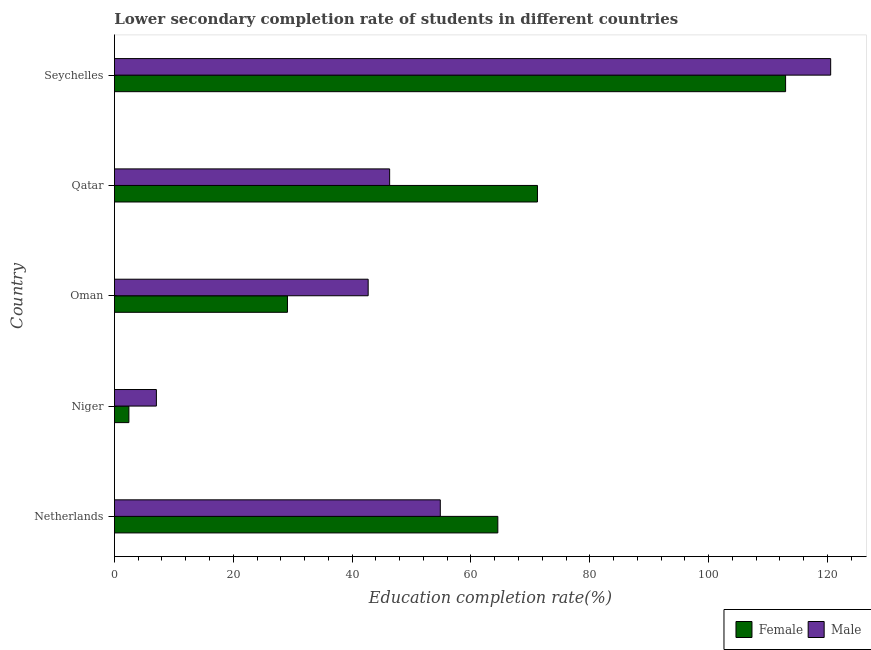How many different coloured bars are there?
Make the answer very short. 2. How many groups of bars are there?
Your response must be concise. 5. Are the number of bars per tick equal to the number of legend labels?
Give a very brief answer. Yes. How many bars are there on the 5th tick from the top?
Your answer should be compact. 2. What is the label of the 5th group of bars from the top?
Your answer should be very brief. Netherlands. What is the education completion rate of male students in Seychelles?
Provide a short and direct response. 120.54. Across all countries, what is the maximum education completion rate of female students?
Your response must be concise. 112.95. Across all countries, what is the minimum education completion rate of female students?
Give a very brief answer. 2.43. In which country was the education completion rate of female students maximum?
Offer a terse response. Seychelles. In which country was the education completion rate of male students minimum?
Offer a terse response. Niger. What is the total education completion rate of male students in the graph?
Give a very brief answer. 271.46. What is the difference between the education completion rate of female students in Netherlands and that in Seychelles?
Your answer should be very brief. -48.43. What is the difference between the education completion rate of male students in Niger and the education completion rate of female students in Qatar?
Give a very brief answer. -64.13. What is the average education completion rate of female students per country?
Provide a succinct answer. 56.05. What is the difference between the education completion rate of male students and education completion rate of female students in Netherlands?
Offer a terse response. -9.68. What is the ratio of the education completion rate of female students in Oman to that in Seychelles?
Keep it short and to the point. 0.26. Is the difference between the education completion rate of male students in Netherlands and Qatar greater than the difference between the education completion rate of female students in Netherlands and Qatar?
Your answer should be very brief. Yes. What is the difference between the highest and the second highest education completion rate of male students?
Offer a very short reply. 65.7. What is the difference between the highest and the lowest education completion rate of female students?
Offer a terse response. 110.52. Is the sum of the education completion rate of male students in Qatar and Seychelles greater than the maximum education completion rate of female students across all countries?
Provide a succinct answer. Yes. What does the 1st bar from the bottom in Netherlands represents?
Offer a terse response. Female. How many bars are there?
Give a very brief answer. 10. How many countries are there in the graph?
Provide a succinct answer. 5. Are the values on the major ticks of X-axis written in scientific E-notation?
Provide a short and direct response. No. Does the graph contain any zero values?
Your response must be concise. No. Does the graph contain grids?
Ensure brevity in your answer.  No. Where does the legend appear in the graph?
Offer a very short reply. Bottom right. How many legend labels are there?
Provide a succinct answer. 2. How are the legend labels stacked?
Give a very brief answer. Horizontal. What is the title of the graph?
Make the answer very short. Lower secondary completion rate of students in different countries. What is the label or title of the X-axis?
Provide a succinct answer. Education completion rate(%). What is the Education completion rate(%) in Female in Netherlands?
Offer a very short reply. 64.52. What is the Education completion rate(%) in Male in Netherlands?
Your response must be concise. 54.84. What is the Education completion rate(%) of Female in Niger?
Keep it short and to the point. 2.43. What is the Education completion rate(%) in Male in Niger?
Keep it short and to the point. 7.06. What is the Education completion rate(%) in Female in Oman?
Your response must be concise. 29.12. What is the Education completion rate(%) of Male in Oman?
Provide a short and direct response. 42.7. What is the Education completion rate(%) of Female in Qatar?
Provide a short and direct response. 71.19. What is the Education completion rate(%) in Male in Qatar?
Ensure brevity in your answer.  46.32. What is the Education completion rate(%) of Female in Seychelles?
Your answer should be compact. 112.95. What is the Education completion rate(%) of Male in Seychelles?
Your response must be concise. 120.54. Across all countries, what is the maximum Education completion rate(%) of Female?
Keep it short and to the point. 112.95. Across all countries, what is the maximum Education completion rate(%) of Male?
Provide a short and direct response. 120.54. Across all countries, what is the minimum Education completion rate(%) of Female?
Offer a very short reply. 2.43. Across all countries, what is the minimum Education completion rate(%) of Male?
Offer a terse response. 7.06. What is the total Education completion rate(%) of Female in the graph?
Your answer should be compact. 280.23. What is the total Education completion rate(%) of Male in the graph?
Give a very brief answer. 271.46. What is the difference between the Education completion rate(%) of Female in Netherlands and that in Niger?
Provide a succinct answer. 62.09. What is the difference between the Education completion rate(%) in Male in Netherlands and that in Niger?
Offer a terse response. 47.78. What is the difference between the Education completion rate(%) of Female in Netherlands and that in Oman?
Keep it short and to the point. 35.4. What is the difference between the Education completion rate(%) in Male in Netherlands and that in Oman?
Provide a short and direct response. 12.14. What is the difference between the Education completion rate(%) in Female in Netherlands and that in Qatar?
Your answer should be compact. -6.67. What is the difference between the Education completion rate(%) of Male in Netherlands and that in Qatar?
Your answer should be very brief. 8.52. What is the difference between the Education completion rate(%) of Female in Netherlands and that in Seychelles?
Provide a succinct answer. -48.43. What is the difference between the Education completion rate(%) of Male in Netherlands and that in Seychelles?
Provide a short and direct response. -65.7. What is the difference between the Education completion rate(%) in Female in Niger and that in Oman?
Offer a terse response. -26.69. What is the difference between the Education completion rate(%) of Male in Niger and that in Oman?
Your response must be concise. -35.64. What is the difference between the Education completion rate(%) in Female in Niger and that in Qatar?
Your answer should be very brief. -68.76. What is the difference between the Education completion rate(%) of Male in Niger and that in Qatar?
Ensure brevity in your answer.  -39.25. What is the difference between the Education completion rate(%) in Female in Niger and that in Seychelles?
Ensure brevity in your answer.  -110.52. What is the difference between the Education completion rate(%) in Male in Niger and that in Seychelles?
Make the answer very short. -113.48. What is the difference between the Education completion rate(%) of Female in Oman and that in Qatar?
Keep it short and to the point. -42.07. What is the difference between the Education completion rate(%) of Male in Oman and that in Qatar?
Give a very brief answer. -3.61. What is the difference between the Education completion rate(%) of Female in Oman and that in Seychelles?
Offer a terse response. -83.83. What is the difference between the Education completion rate(%) of Male in Oman and that in Seychelles?
Keep it short and to the point. -77.84. What is the difference between the Education completion rate(%) of Female in Qatar and that in Seychelles?
Give a very brief answer. -41.76. What is the difference between the Education completion rate(%) in Male in Qatar and that in Seychelles?
Your answer should be compact. -74.22. What is the difference between the Education completion rate(%) of Female in Netherlands and the Education completion rate(%) of Male in Niger?
Keep it short and to the point. 57.46. What is the difference between the Education completion rate(%) in Female in Netherlands and the Education completion rate(%) in Male in Oman?
Offer a very short reply. 21.82. What is the difference between the Education completion rate(%) in Female in Netherlands and the Education completion rate(%) in Male in Qatar?
Make the answer very short. 18.21. What is the difference between the Education completion rate(%) of Female in Netherlands and the Education completion rate(%) of Male in Seychelles?
Your answer should be compact. -56.02. What is the difference between the Education completion rate(%) in Female in Niger and the Education completion rate(%) in Male in Oman?
Make the answer very short. -40.27. What is the difference between the Education completion rate(%) of Female in Niger and the Education completion rate(%) of Male in Qatar?
Offer a terse response. -43.88. What is the difference between the Education completion rate(%) in Female in Niger and the Education completion rate(%) in Male in Seychelles?
Keep it short and to the point. -118.11. What is the difference between the Education completion rate(%) of Female in Oman and the Education completion rate(%) of Male in Qatar?
Keep it short and to the point. -17.19. What is the difference between the Education completion rate(%) of Female in Oman and the Education completion rate(%) of Male in Seychelles?
Give a very brief answer. -91.42. What is the difference between the Education completion rate(%) in Female in Qatar and the Education completion rate(%) in Male in Seychelles?
Ensure brevity in your answer.  -49.35. What is the average Education completion rate(%) in Female per country?
Your answer should be very brief. 56.05. What is the average Education completion rate(%) of Male per country?
Offer a terse response. 54.29. What is the difference between the Education completion rate(%) in Female and Education completion rate(%) in Male in Netherlands?
Ensure brevity in your answer.  9.68. What is the difference between the Education completion rate(%) in Female and Education completion rate(%) in Male in Niger?
Offer a terse response. -4.63. What is the difference between the Education completion rate(%) in Female and Education completion rate(%) in Male in Oman?
Make the answer very short. -13.58. What is the difference between the Education completion rate(%) in Female and Education completion rate(%) in Male in Qatar?
Offer a terse response. 24.88. What is the difference between the Education completion rate(%) of Female and Education completion rate(%) of Male in Seychelles?
Your answer should be very brief. -7.59. What is the ratio of the Education completion rate(%) of Female in Netherlands to that in Niger?
Keep it short and to the point. 26.52. What is the ratio of the Education completion rate(%) of Male in Netherlands to that in Niger?
Offer a terse response. 7.76. What is the ratio of the Education completion rate(%) in Female in Netherlands to that in Oman?
Keep it short and to the point. 2.22. What is the ratio of the Education completion rate(%) in Male in Netherlands to that in Oman?
Ensure brevity in your answer.  1.28. What is the ratio of the Education completion rate(%) in Female in Netherlands to that in Qatar?
Provide a short and direct response. 0.91. What is the ratio of the Education completion rate(%) of Male in Netherlands to that in Qatar?
Keep it short and to the point. 1.18. What is the ratio of the Education completion rate(%) of Female in Netherlands to that in Seychelles?
Offer a terse response. 0.57. What is the ratio of the Education completion rate(%) of Male in Netherlands to that in Seychelles?
Give a very brief answer. 0.46. What is the ratio of the Education completion rate(%) of Female in Niger to that in Oman?
Give a very brief answer. 0.08. What is the ratio of the Education completion rate(%) in Male in Niger to that in Oman?
Ensure brevity in your answer.  0.17. What is the ratio of the Education completion rate(%) of Female in Niger to that in Qatar?
Keep it short and to the point. 0.03. What is the ratio of the Education completion rate(%) in Male in Niger to that in Qatar?
Your answer should be compact. 0.15. What is the ratio of the Education completion rate(%) in Female in Niger to that in Seychelles?
Keep it short and to the point. 0.02. What is the ratio of the Education completion rate(%) in Male in Niger to that in Seychelles?
Offer a very short reply. 0.06. What is the ratio of the Education completion rate(%) of Female in Oman to that in Qatar?
Your answer should be very brief. 0.41. What is the ratio of the Education completion rate(%) of Male in Oman to that in Qatar?
Keep it short and to the point. 0.92. What is the ratio of the Education completion rate(%) in Female in Oman to that in Seychelles?
Your answer should be very brief. 0.26. What is the ratio of the Education completion rate(%) in Male in Oman to that in Seychelles?
Offer a very short reply. 0.35. What is the ratio of the Education completion rate(%) of Female in Qatar to that in Seychelles?
Give a very brief answer. 0.63. What is the ratio of the Education completion rate(%) of Male in Qatar to that in Seychelles?
Your answer should be very brief. 0.38. What is the difference between the highest and the second highest Education completion rate(%) of Female?
Offer a terse response. 41.76. What is the difference between the highest and the second highest Education completion rate(%) of Male?
Offer a terse response. 65.7. What is the difference between the highest and the lowest Education completion rate(%) in Female?
Provide a short and direct response. 110.52. What is the difference between the highest and the lowest Education completion rate(%) of Male?
Provide a succinct answer. 113.48. 